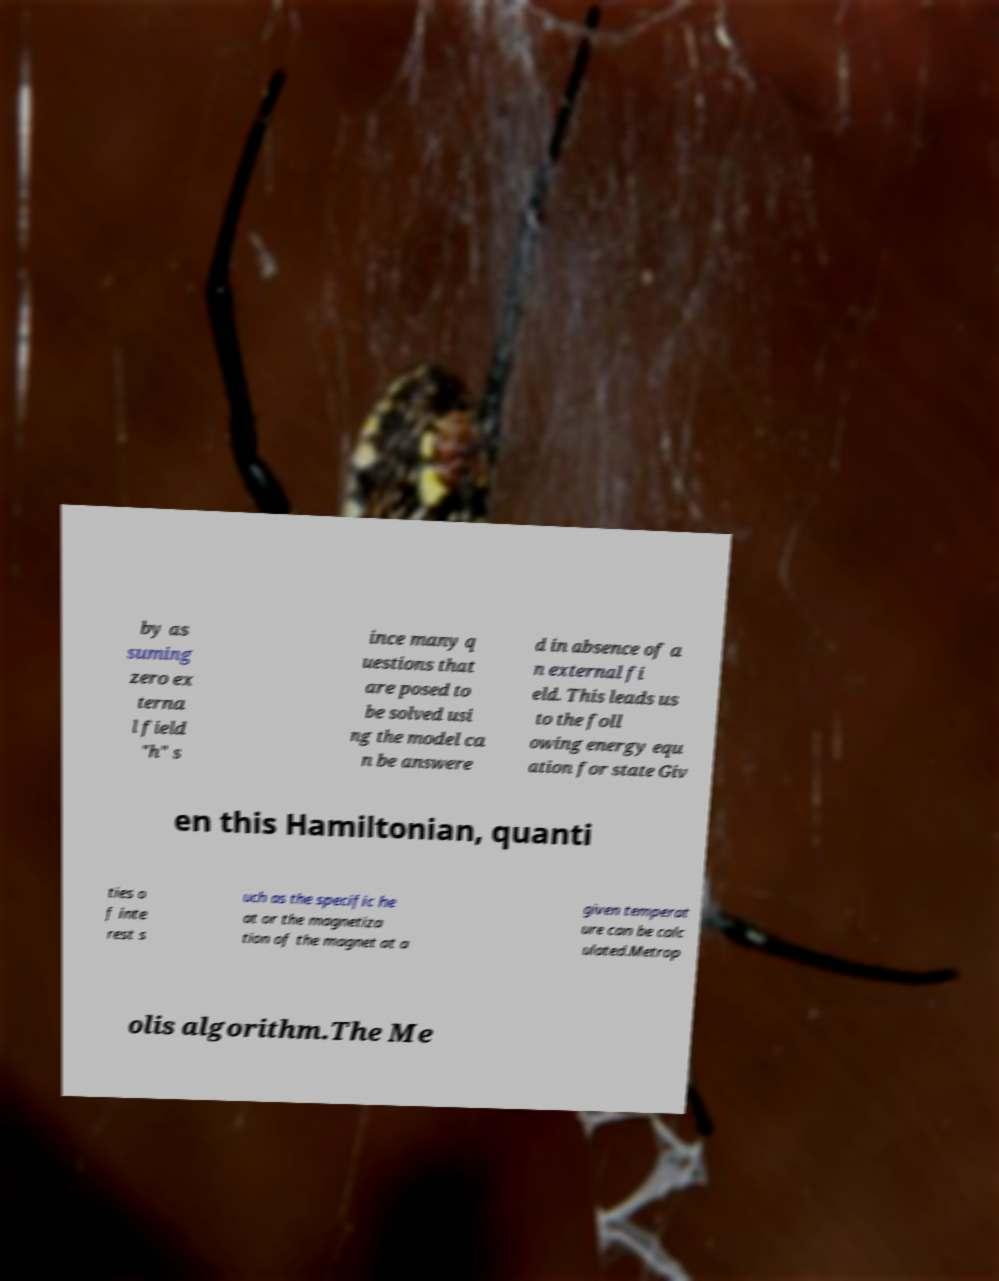Could you assist in decoding the text presented in this image and type it out clearly? by as suming zero ex terna l field "h" s ince many q uestions that are posed to be solved usi ng the model ca n be answere d in absence of a n external fi eld. This leads us to the foll owing energy equ ation for state Giv en this Hamiltonian, quanti ties o f inte rest s uch as the specific he at or the magnetiza tion of the magnet at a given temperat ure can be calc ulated.Metrop olis algorithm.The Me 